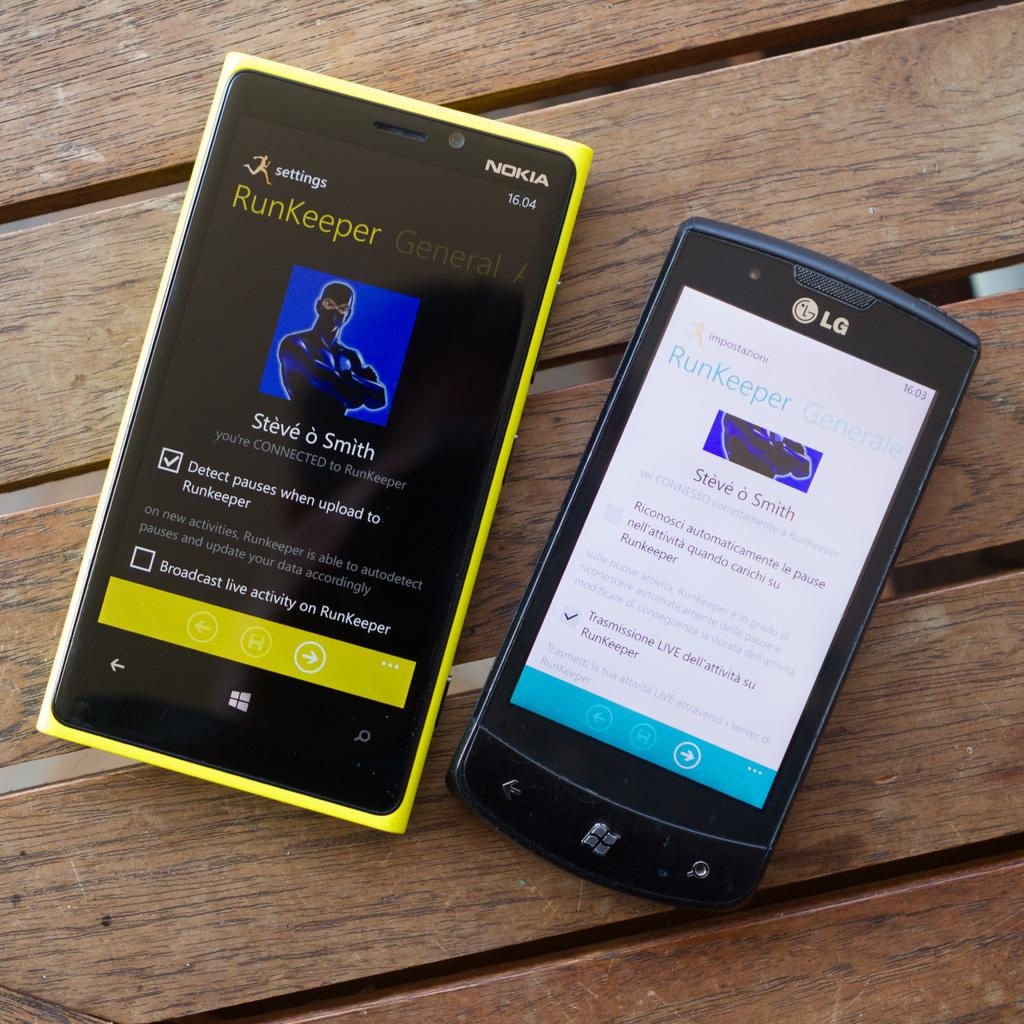<image>
Write a terse but informative summary of the picture. The app on the Nokia smartphone is called Runkeeper. 